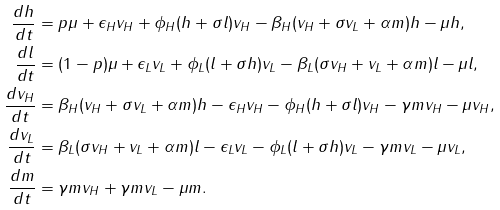Convert formula to latex. <formula><loc_0><loc_0><loc_500><loc_500>\frac { d h } { d t } & = p \mu + \epsilon _ { H } v _ { H } + \phi _ { H } ( h + \sigma l ) v _ { H } - \beta _ { H } ( v _ { H } + \sigma v _ { L } + \alpha m ) h - \mu h , \\ \frac { d l } { d t } & = ( 1 - p ) \mu + \epsilon _ { L } v _ { L } + \phi _ { L } ( l + \sigma h ) v _ { L } - \beta _ { L } ( \sigma v _ { H } + v _ { L } + \alpha m ) l - \mu l , \\ \frac { d v _ { H } } { d t } & = \beta _ { H } ( v _ { H } + \sigma v _ { L } + \alpha m ) h - \epsilon _ { H } v _ { H } - \phi _ { H } ( h + \sigma l ) v _ { H } - \gamma m v _ { H } - \mu v _ { H } , \\ \frac { d v _ { L } } { d t } & = \beta _ { L } ( \sigma v _ { H } + v _ { L } + \alpha m ) l - \epsilon _ { L } v _ { L } - \phi _ { L } ( l + \sigma h ) v _ { L } - \gamma m v _ { L } - \mu v _ { L } , \\ \frac { d m } { d t } & = \gamma m v _ { H } + \gamma m v _ { L } - \mu m .</formula> 